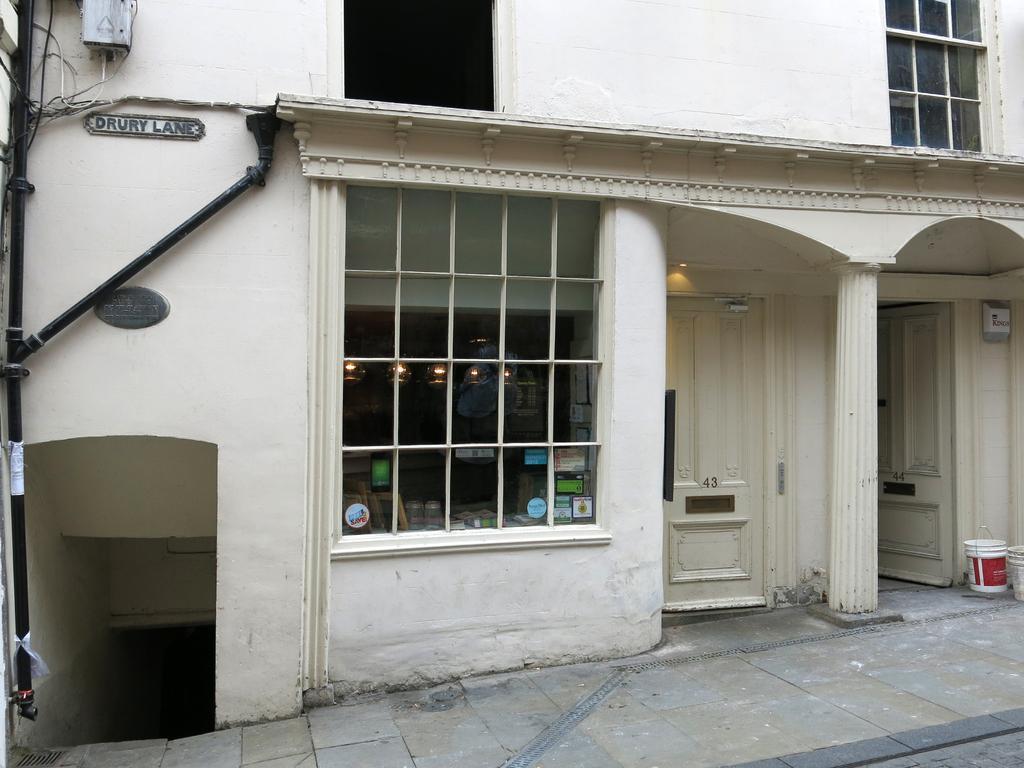Please provide a concise description of this image. In this image we can see a building. On the building we can see windows and doors. Through the glass of the window we can see few objects and lights. On the right side, we can see two buckets and on the left side, we can see pipes and some text on the building. 